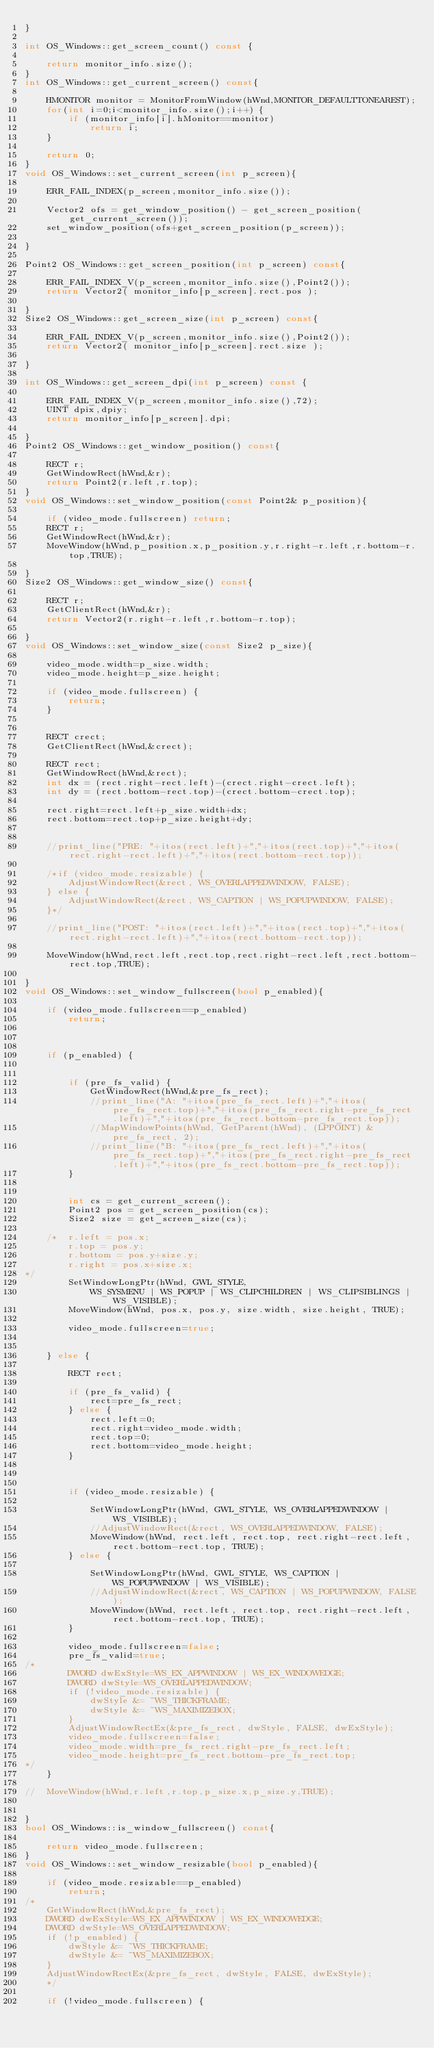<code> <loc_0><loc_0><loc_500><loc_500><_C++_>}

int OS_Windows::get_screen_count() const {

	return monitor_info.size();
}
int OS_Windows::get_current_screen() const{

	HMONITOR monitor = MonitorFromWindow(hWnd,MONITOR_DEFAULTTONEAREST);
	for(int i=0;i<monitor_info.size();i++) {
		if (monitor_info[i].hMonitor==monitor)
			return i;
	}

	return 0;
}
void OS_Windows::set_current_screen(int p_screen){

	ERR_FAIL_INDEX(p_screen,monitor_info.size());

	Vector2 ofs = get_window_position() - get_screen_position(get_current_screen());
	set_window_position(ofs+get_screen_position(p_screen));

}

Point2 OS_Windows::get_screen_position(int p_screen) const{

	ERR_FAIL_INDEX_V(p_screen,monitor_info.size(),Point2());
	return Vector2( monitor_info[p_screen].rect.pos );

}
Size2 OS_Windows::get_screen_size(int p_screen) const{

	ERR_FAIL_INDEX_V(p_screen,monitor_info.size(),Point2());
	return Vector2( monitor_info[p_screen].rect.size );

}

int OS_Windows::get_screen_dpi(int p_screen) const {

	ERR_FAIL_INDEX_V(p_screen,monitor_info.size(),72);
	UINT dpix,dpiy;
	return monitor_info[p_screen].dpi;

}
Point2 OS_Windows::get_window_position() const{

	RECT r;
	GetWindowRect(hWnd,&r);
	return Point2(r.left,r.top);
}
void OS_Windows::set_window_position(const Point2& p_position){

	if (video_mode.fullscreen) return;
	RECT r;
	GetWindowRect(hWnd,&r);
	MoveWindow(hWnd,p_position.x,p_position.y,r.right-r.left,r.bottom-r.top,TRUE);

}
Size2 OS_Windows::get_window_size() const{

	RECT r;
	GetClientRect(hWnd,&r);
	return Vector2(r.right-r.left,r.bottom-r.top);

}
void OS_Windows::set_window_size(const Size2 p_size){

	video_mode.width=p_size.width;
	video_mode.height=p_size.height;

	if (video_mode.fullscreen) {
		return;
	}


	RECT crect;
	GetClientRect(hWnd,&crect);

	RECT rect;
	GetWindowRect(hWnd,&rect);
	int dx = (rect.right-rect.left)-(crect.right-crect.left);
	int dy = (rect.bottom-rect.top)-(crect.bottom-crect.top);

	rect.right=rect.left+p_size.width+dx;
	rect.bottom=rect.top+p_size.height+dy;


	//print_line("PRE: "+itos(rect.left)+","+itos(rect.top)+","+itos(rect.right-rect.left)+","+itos(rect.bottom-rect.top));

	/*if (video_mode.resizable) {
		AdjustWindowRect(&rect, WS_OVERLAPPEDWINDOW, FALSE);
	} else {
		AdjustWindowRect(&rect, WS_CAPTION | WS_POPUPWINDOW, FALSE);
	}*/

	//print_line("POST: "+itos(rect.left)+","+itos(rect.top)+","+itos(rect.right-rect.left)+","+itos(rect.bottom-rect.top));

	MoveWindow(hWnd,rect.left,rect.top,rect.right-rect.left,rect.bottom-rect.top,TRUE);

}
void OS_Windows::set_window_fullscreen(bool p_enabled){

	if (video_mode.fullscreen==p_enabled)
		return;



	if (p_enabled) {


		if (pre_fs_valid) {
			GetWindowRect(hWnd,&pre_fs_rect);
			//print_line("A: "+itos(pre_fs_rect.left)+","+itos(pre_fs_rect.top)+","+itos(pre_fs_rect.right-pre_fs_rect.left)+","+itos(pre_fs_rect.bottom-pre_fs_rect.top));
			//MapWindowPoints(hWnd, GetParent(hWnd), (LPPOINT) &pre_fs_rect, 2);
			//print_line("B: "+itos(pre_fs_rect.left)+","+itos(pre_fs_rect.top)+","+itos(pre_fs_rect.right-pre_fs_rect.left)+","+itos(pre_fs_rect.bottom-pre_fs_rect.top));
		}


		int cs = get_current_screen();
		Point2 pos = get_screen_position(cs);
		Size2 size = get_screen_size(cs);

	/*	r.left = pos.x;
		r.top = pos.y;
		r.bottom = pos.y+size.y;
		r.right = pos.x+size.x;
*/
		SetWindowLongPtr(hWnd, GWL_STYLE,
		    WS_SYSMENU | WS_POPUP | WS_CLIPCHILDREN | WS_CLIPSIBLINGS | WS_VISIBLE);
		MoveWindow(hWnd, pos.x, pos.y, size.width, size.height, TRUE);

		video_mode.fullscreen=true;


	} else {

		RECT rect;

		if (pre_fs_valid) {
			rect=pre_fs_rect;
		} else {
			rect.left=0;
			rect.right=video_mode.width;
			rect.top=0;
			rect.bottom=video_mode.height;
		}



		if (video_mode.resizable) {

			SetWindowLongPtr(hWnd, GWL_STYLE, WS_OVERLAPPEDWINDOW | WS_VISIBLE);
			//AdjustWindowRect(&rect, WS_OVERLAPPEDWINDOW, FALSE);
			MoveWindow(hWnd, rect.left, rect.top, rect.right-rect.left, rect.bottom-rect.top, TRUE);
		} else {

			SetWindowLongPtr(hWnd, GWL_STYLE, WS_CAPTION | WS_POPUPWINDOW | WS_VISIBLE);
			//AdjustWindowRect(&rect, WS_CAPTION | WS_POPUPWINDOW, FALSE);
			MoveWindow(hWnd, rect.left, rect.top, rect.right-rect.left, rect.bottom-rect.top, TRUE);
		}

		video_mode.fullscreen=false;
		pre_fs_valid=true;
/*
		DWORD dwExStyle=WS_EX_APPWINDOW | WS_EX_WINDOWEDGE;
		DWORD dwStyle=WS_OVERLAPPEDWINDOW;
		if (!video_mode.resizable) {
			dwStyle &= ~WS_THICKFRAME;
			dwStyle &= ~WS_MAXIMIZEBOX;
		}
		AdjustWindowRectEx(&pre_fs_rect, dwStyle, FALSE, dwExStyle);
		video_mode.fullscreen=false;
		video_mode.width=pre_fs_rect.right-pre_fs_rect.left;
		video_mode.height=pre_fs_rect.bottom-pre_fs_rect.top;
*/
	}

//	MoveWindow(hWnd,r.left,r.top,p_size.x,p_size.y,TRUE);


}
bool OS_Windows::is_window_fullscreen() const{

	return video_mode.fullscreen;
}
void OS_Windows::set_window_resizable(bool p_enabled){

	if (video_mode.resizable==p_enabled)
		return;
/*
	GetWindowRect(hWnd,&pre_fs_rect);
	DWORD dwExStyle=WS_EX_APPWINDOW | WS_EX_WINDOWEDGE;
	DWORD dwStyle=WS_OVERLAPPEDWINDOW;
	if (!p_enabled) {
		dwStyle &= ~WS_THICKFRAME;
		dwStyle &= ~WS_MAXIMIZEBOX;
	}
	AdjustWindowRectEx(&pre_fs_rect, dwStyle, FALSE, dwExStyle);
	*/

	if (!video_mode.fullscreen) {</code> 